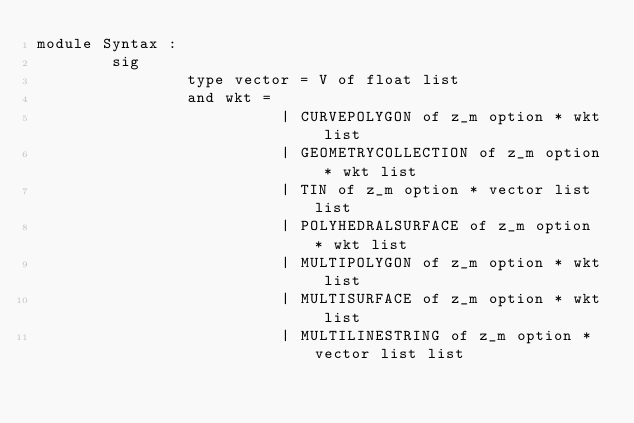Convert code to text. <code><loc_0><loc_0><loc_500><loc_500><_OCaml_>module Syntax :
        sig
                type vector = V of float list
                and wkt =
                          | CURVEPOLYGON of z_m option * wkt list
                          | GEOMETRYCOLLECTION of z_m option * wkt list
                          | TIN of z_m option * vector list list
                          | POLYHEDRALSURFACE of z_m option * wkt list
                          | MULTIPOLYGON of z_m option * wkt list
                          | MULTISURFACE of z_m option * wkt list
                          | MULTILINESTRING of z_m option * vector list list</code> 